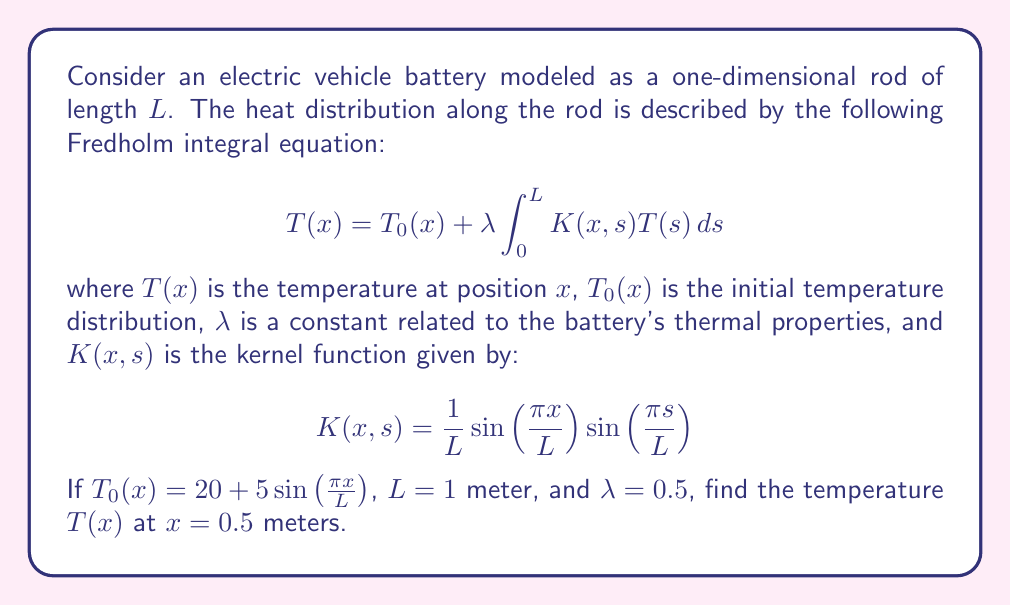Solve this math problem. To solve this problem, we'll follow these steps:

1) First, we need to recognize that this is a Fredholm integral equation of the second kind. The solution can be approximated using the method of successive approximations (Picard iteration).

2) We start with the initial approximation $T_0(x) = 20 + 5\sin(\frac{\pi x}{L})$.

3) For the next approximation, we substitute this into the right-hand side of the equation:

   $$T_1(x) = T_0(x) + \lambda \int_0^L K(x,s)T_0(s)ds$$

4) Let's evaluate the integral:

   $$\int_0^L K(x,s)T_0(s)ds = \int_0^1 \sin(\pi x)\sin(\pi s)(20 + 5\sin(\pi s))ds$$

   $$= 20\sin(\pi x)\int_0^1 \sin(\pi s)ds + 5\sin(\pi x)\int_0^1 \sin^2(\pi s)ds$$

   $$= 20\sin(\pi x) \cdot 0 + 5\sin(\pi x) \cdot \frac{1}{2} = \frac{5}{2}\sin(\pi x)$$

5) Therefore, 

   $$T_1(x) = 20 + 5\sin(\pi x) + 0.5 \cdot \frac{5}{2}\sin(\pi x) = 20 + 6.25\sin(\pi x)$$

6) We could continue this process for more iterations, but let's stop here for an approximation.

7) To find $T(0.5)$, we substitute $x = 0.5$ into our approximation:

   $$T(0.5) \approx 20 + 6.25\sin(\pi \cdot 0.5) = 20 + 6.25 = 26.25$$
Answer: $26.25$ °C 